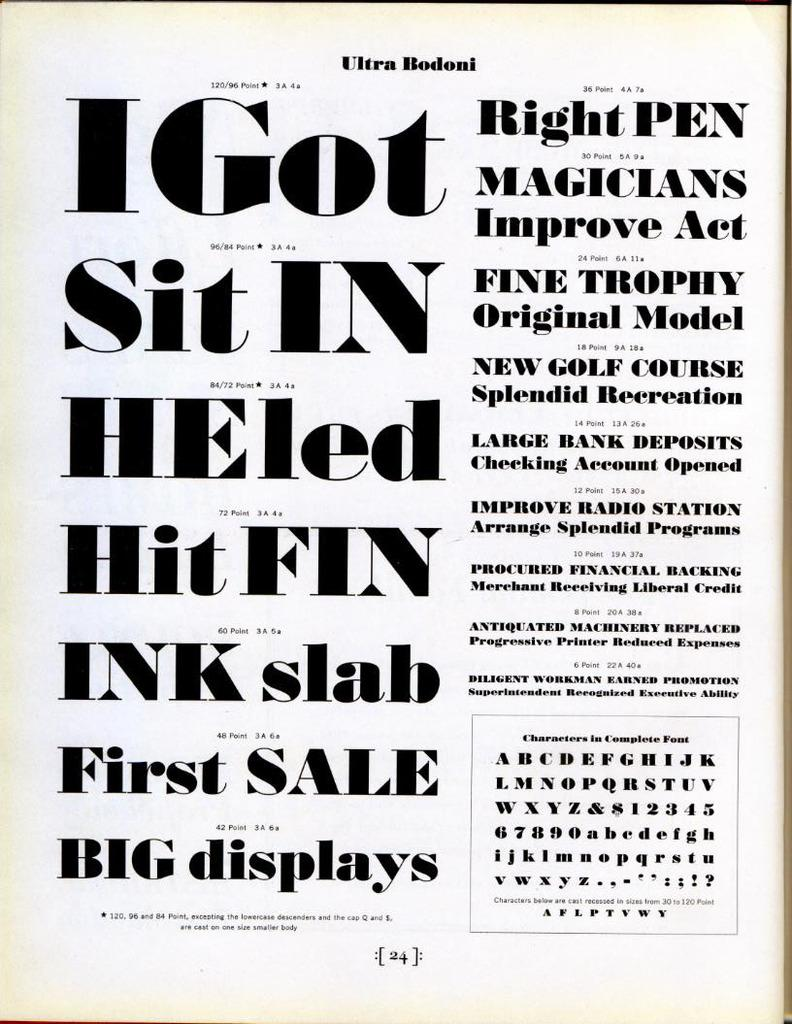Provide a one-sentence caption for the provided image. An old poster from Ultra Bodoni with various font. 